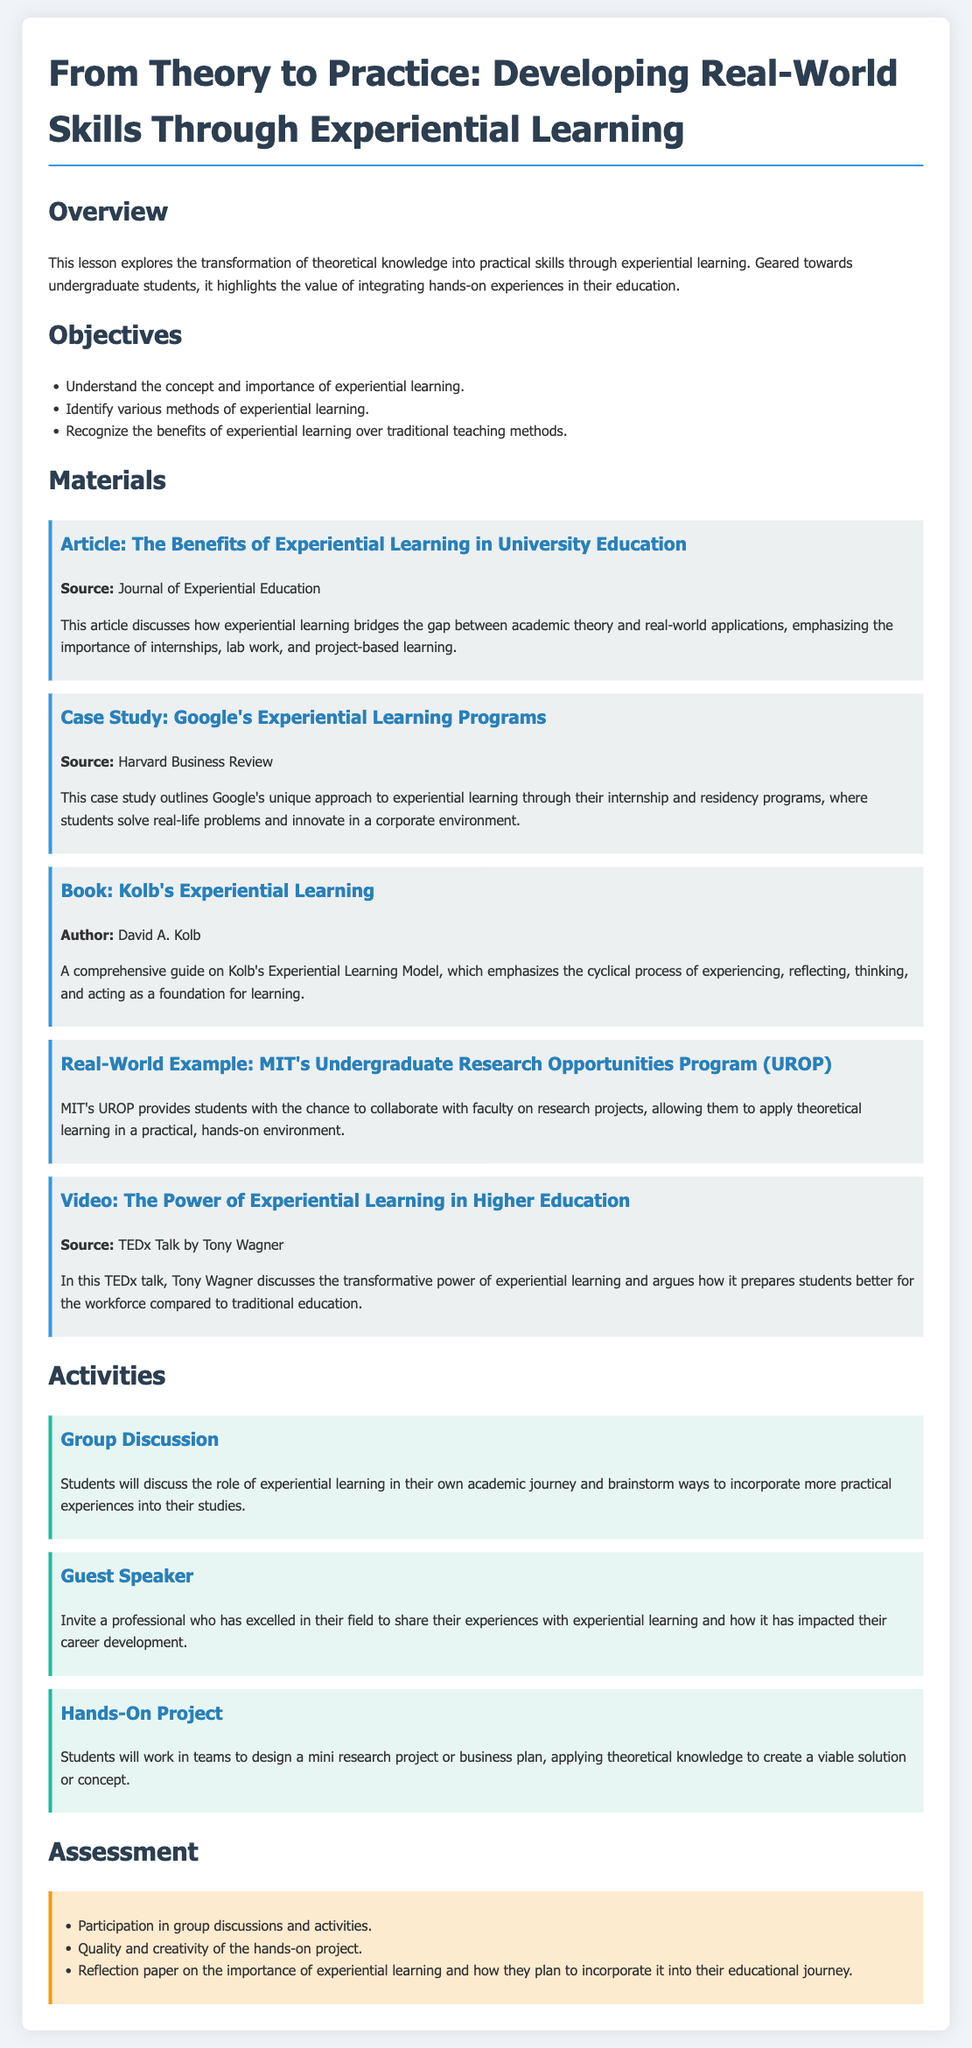what is the title of the lesson plan? The title is explicitly stated at the beginning of the document.
Answer: From Theory to Practice: Developing Real-World Skills Through Experiential Learning what is one objective of the lesson? The objectives are listed in a bullet format, highlighting what students should achieve.
Answer: Understand the concept and importance of experiential learning who is the author of "Kolb's Experiential Learning"? The author is mentioned in the context of the materials provided in the lesson plan.
Answer: David A. Kolb name one method of experiential learning mentioned in the document. The document discusses various methods, including practical experiences and different programs.
Answer: Internships what organization is associated with the UROP example? The example illustrates a real-world application of experiential learning linked to an educational institution.
Answer: MIT how will students be assessed? The assessment criteria are outlined in a list format towards the end of the lesson plan.
Answer: Participation in group discussions and activities who delivered the TEDx talk mentioned in the materials? The source provides the name of the speaker along with the content of the talk.
Answer: Tony Wagner what type of project will students complete as part of the hands-on activity? The activities detail a specific type of project students will work on during the hands-on session.
Answer: Mini research project or business plan what is one benefit of experiential learning suggested in the overview? The overview states the educational value of experiential learning and its advantages over traditional methods.
Answer: Bridges the gap between academic theory and real-world applications 